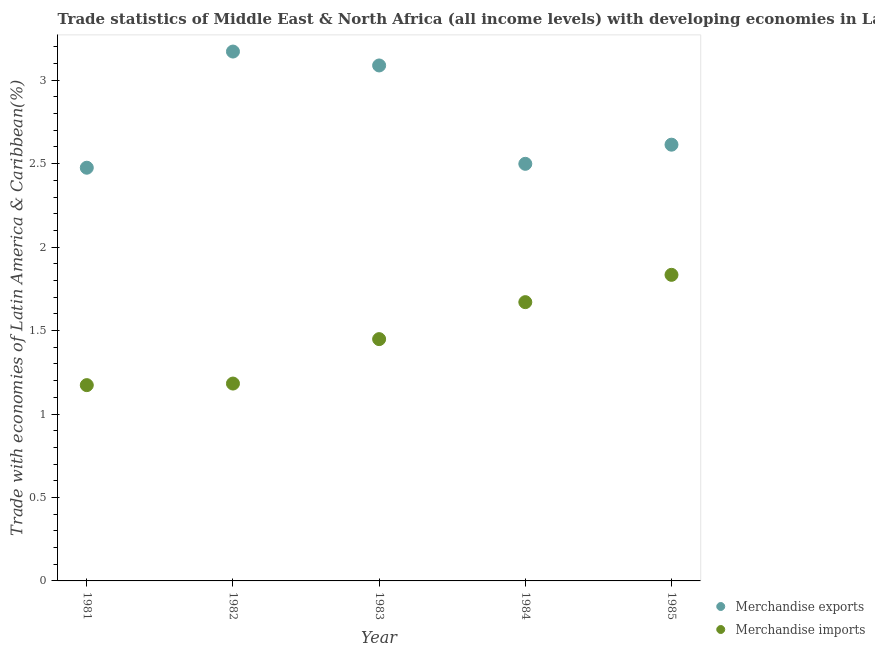What is the merchandise exports in 1981?
Keep it short and to the point. 2.48. Across all years, what is the maximum merchandise exports?
Offer a very short reply. 3.17. Across all years, what is the minimum merchandise imports?
Provide a short and direct response. 1.17. In which year was the merchandise imports minimum?
Keep it short and to the point. 1981. What is the total merchandise imports in the graph?
Give a very brief answer. 7.31. What is the difference between the merchandise imports in 1981 and that in 1983?
Offer a terse response. -0.28. What is the difference between the merchandise exports in 1982 and the merchandise imports in 1983?
Offer a terse response. 1.72. What is the average merchandise exports per year?
Your response must be concise. 2.77. In the year 1985, what is the difference between the merchandise imports and merchandise exports?
Ensure brevity in your answer.  -0.78. What is the ratio of the merchandise imports in 1982 to that in 1984?
Make the answer very short. 0.71. Is the merchandise exports in 1982 less than that in 1985?
Give a very brief answer. No. What is the difference between the highest and the second highest merchandise imports?
Keep it short and to the point. 0.16. What is the difference between the highest and the lowest merchandise exports?
Offer a terse response. 0.7. Is the sum of the merchandise imports in 1983 and 1985 greater than the maximum merchandise exports across all years?
Your answer should be very brief. Yes. Is the merchandise exports strictly less than the merchandise imports over the years?
Offer a terse response. No. How many dotlines are there?
Ensure brevity in your answer.  2. How many years are there in the graph?
Make the answer very short. 5. What is the difference between two consecutive major ticks on the Y-axis?
Your answer should be compact. 0.5. Does the graph contain any zero values?
Your answer should be compact. No. Where does the legend appear in the graph?
Offer a terse response. Bottom right. How many legend labels are there?
Keep it short and to the point. 2. What is the title of the graph?
Your response must be concise. Trade statistics of Middle East & North Africa (all income levels) with developing economies in Latin America. What is the label or title of the X-axis?
Offer a very short reply. Year. What is the label or title of the Y-axis?
Offer a very short reply. Trade with economies of Latin America & Caribbean(%). What is the Trade with economies of Latin America & Caribbean(%) in Merchandise exports in 1981?
Provide a succinct answer. 2.48. What is the Trade with economies of Latin America & Caribbean(%) in Merchandise imports in 1981?
Your answer should be compact. 1.17. What is the Trade with economies of Latin America & Caribbean(%) in Merchandise exports in 1982?
Offer a very short reply. 3.17. What is the Trade with economies of Latin America & Caribbean(%) in Merchandise imports in 1982?
Ensure brevity in your answer.  1.18. What is the Trade with economies of Latin America & Caribbean(%) in Merchandise exports in 1983?
Ensure brevity in your answer.  3.09. What is the Trade with economies of Latin America & Caribbean(%) in Merchandise imports in 1983?
Your answer should be compact. 1.45. What is the Trade with economies of Latin America & Caribbean(%) of Merchandise exports in 1984?
Offer a very short reply. 2.5. What is the Trade with economies of Latin America & Caribbean(%) in Merchandise imports in 1984?
Ensure brevity in your answer.  1.67. What is the Trade with economies of Latin America & Caribbean(%) of Merchandise exports in 1985?
Offer a very short reply. 2.61. What is the Trade with economies of Latin America & Caribbean(%) in Merchandise imports in 1985?
Provide a succinct answer. 1.83. Across all years, what is the maximum Trade with economies of Latin America & Caribbean(%) of Merchandise exports?
Keep it short and to the point. 3.17. Across all years, what is the maximum Trade with economies of Latin America & Caribbean(%) of Merchandise imports?
Ensure brevity in your answer.  1.83. Across all years, what is the minimum Trade with economies of Latin America & Caribbean(%) of Merchandise exports?
Your answer should be very brief. 2.48. Across all years, what is the minimum Trade with economies of Latin America & Caribbean(%) in Merchandise imports?
Your answer should be very brief. 1.17. What is the total Trade with economies of Latin America & Caribbean(%) in Merchandise exports in the graph?
Give a very brief answer. 13.85. What is the total Trade with economies of Latin America & Caribbean(%) in Merchandise imports in the graph?
Keep it short and to the point. 7.31. What is the difference between the Trade with economies of Latin America & Caribbean(%) in Merchandise exports in 1981 and that in 1982?
Provide a short and direct response. -0.7. What is the difference between the Trade with economies of Latin America & Caribbean(%) of Merchandise imports in 1981 and that in 1982?
Your answer should be very brief. -0.01. What is the difference between the Trade with economies of Latin America & Caribbean(%) of Merchandise exports in 1981 and that in 1983?
Your answer should be compact. -0.61. What is the difference between the Trade with economies of Latin America & Caribbean(%) in Merchandise imports in 1981 and that in 1983?
Your answer should be compact. -0.28. What is the difference between the Trade with economies of Latin America & Caribbean(%) in Merchandise exports in 1981 and that in 1984?
Your response must be concise. -0.02. What is the difference between the Trade with economies of Latin America & Caribbean(%) in Merchandise imports in 1981 and that in 1984?
Offer a very short reply. -0.5. What is the difference between the Trade with economies of Latin America & Caribbean(%) of Merchandise exports in 1981 and that in 1985?
Make the answer very short. -0.14. What is the difference between the Trade with economies of Latin America & Caribbean(%) in Merchandise imports in 1981 and that in 1985?
Make the answer very short. -0.66. What is the difference between the Trade with economies of Latin America & Caribbean(%) in Merchandise exports in 1982 and that in 1983?
Provide a succinct answer. 0.08. What is the difference between the Trade with economies of Latin America & Caribbean(%) in Merchandise imports in 1982 and that in 1983?
Give a very brief answer. -0.27. What is the difference between the Trade with economies of Latin America & Caribbean(%) in Merchandise exports in 1982 and that in 1984?
Provide a short and direct response. 0.67. What is the difference between the Trade with economies of Latin America & Caribbean(%) in Merchandise imports in 1982 and that in 1984?
Your response must be concise. -0.49. What is the difference between the Trade with economies of Latin America & Caribbean(%) in Merchandise exports in 1982 and that in 1985?
Your response must be concise. 0.56. What is the difference between the Trade with economies of Latin America & Caribbean(%) in Merchandise imports in 1982 and that in 1985?
Your answer should be very brief. -0.65. What is the difference between the Trade with economies of Latin America & Caribbean(%) in Merchandise exports in 1983 and that in 1984?
Give a very brief answer. 0.59. What is the difference between the Trade with economies of Latin America & Caribbean(%) in Merchandise imports in 1983 and that in 1984?
Offer a very short reply. -0.22. What is the difference between the Trade with economies of Latin America & Caribbean(%) in Merchandise exports in 1983 and that in 1985?
Keep it short and to the point. 0.47. What is the difference between the Trade with economies of Latin America & Caribbean(%) of Merchandise imports in 1983 and that in 1985?
Give a very brief answer. -0.39. What is the difference between the Trade with economies of Latin America & Caribbean(%) of Merchandise exports in 1984 and that in 1985?
Offer a very short reply. -0.11. What is the difference between the Trade with economies of Latin America & Caribbean(%) in Merchandise imports in 1984 and that in 1985?
Provide a succinct answer. -0.16. What is the difference between the Trade with economies of Latin America & Caribbean(%) of Merchandise exports in 1981 and the Trade with economies of Latin America & Caribbean(%) of Merchandise imports in 1982?
Offer a terse response. 1.29. What is the difference between the Trade with economies of Latin America & Caribbean(%) in Merchandise exports in 1981 and the Trade with economies of Latin America & Caribbean(%) in Merchandise imports in 1983?
Offer a terse response. 1.03. What is the difference between the Trade with economies of Latin America & Caribbean(%) in Merchandise exports in 1981 and the Trade with economies of Latin America & Caribbean(%) in Merchandise imports in 1984?
Offer a terse response. 0.81. What is the difference between the Trade with economies of Latin America & Caribbean(%) of Merchandise exports in 1981 and the Trade with economies of Latin America & Caribbean(%) of Merchandise imports in 1985?
Ensure brevity in your answer.  0.64. What is the difference between the Trade with economies of Latin America & Caribbean(%) of Merchandise exports in 1982 and the Trade with economies of Latin America & Caribbean(%) of Merchandise imports in 1983?
Your response must be concise. 1.72. What is the difference between the Trade with economies of Latin America & Caribbean(%) in Merchandise exports in 1982 and the Trade with economies of Latin America & Caribbean(%) in Merchandise imports in 1984?
Make the answer very short. 1.5. What is the difference between the Trade with economies of Latin America & Caribbean(%) in Merchandise exports in 1982 and the Trade with economies of Latin America & Caribbean(%) in Merchandise imports in 1985?
Ensure brevity in your answer.  1.34. What is the difference between the Trade with economies of Latin America & Caribbean(%) of Merchandise exports in 1983 and the Trade with economies of Latin America & Caribbean(%) of Merchandise imports in 1984?
Provide a succinct answer. 1.42. What is the difference between the Trade with economies of Latin America & Caribbean(%) in Merchandise exports in 1983 and the Trade with economies of Latin America & Caribbean(%) in Merchandise imports in 1985?
Your answer should be compact. 1.25. What is the difference between the Trade with economies of Latin America & Caribbean(%) of Merchandise exports in 1984 and the Trade with economies of Latin America & Caribbean(%) of Merchandise imports in 1985?
Your answer should be compact. 0.67. What is the average Trade with economies of Latin America & Caribbean(%) in Merchandise exports per year?
Offer a terse response. 2.77. What is the average Trade with economies of Latin America & Caribbean(%) in Merchandise imports per year?
Give a very brief answer. 1.46. In the year 1981, what is the difference between the Trade with economies of Latin America & Caribbean(%) in Merchandise exports and Trade with economies of Latin America & Caribbean(%) in Merchandise imports?
Your answer should be compact. 1.3. In the year 1982, what is the difference between the Trade with economies of Latin America & Caribbean(%) in Merchandise exports and Trade with economies of Latin America & Caribbean(%) in Merchandise imports?
Provide a short and direct response. 1.99. In the year 1983, what is the difference between the Trade with economies of Latin America & Caribbean(%) in Merchandise exports and Trade with economies of Latin America & Caribbean(%) in Merchandise imports?
Ensure brevity in your answer.  1.64. In the year 1984, what is the difference between the Trade with economies of Latin America & Caribbean(%) of Merchandise exports and Trade with economies of Latin America & Caribbean(%) of Merchandise imports?
Provide a succinct answer. 0.83. In the year 1985, what is the difference between the Trade with economies of Latin America & Caribbean(%) of Merchandise exports and Trade with economies of Latin America & Caribbean(%) of Merchandise imports?
Offer a very short reply. 0.78. What is the ratio of the Trade with economies of Latin America & Caribbean(%) in Merchandise exports in 1981 to that in 1982?
Your answer should be very brief. 0.78. What is the ratio of the Trade with economies of Latin America & Caribbean(%) in Merchandise imports in 1981 to that in 1982?
Ensure brevity in your answer.  0.99. What is the ratio of the Trade with economies of Latin America & Caribbean(%) of Merchandise exports in 1981 to that in 1983?
Keep it short and to the point. 0.8. What is the ratio of the Trade with economies of Latin America & Caribbean(%) in Merchandise imports in 1981 to that in 1983?
Offer a very short reply. 0.81. What is the ratio of the Trade with economies of Latin America & Caribbean(%) of Merchandise exports in 1981 to that in 1984?
Offer a terse response. 0.99. What is the ratio of the Trade with economies of Latin America & Caribbean(%) of Merchandise imports in 1981 to that in 1984?
Provide a short and direct response. 0.7. What is the ratio of the Trade with economies of Latin America & Caribbean(%) in Merchandise exports in 1981 to that in 1985?
Keep it short and to the point. 0.95. What is the ratio of the Trade with economies of Latin America & Caribbean(%) of Merchandise imports in 1981 to that in 1985?
Ensure brevity in your answer.  0.64. What is the ratio of the Trade with economies of Latin America & Caribbean(%) of Merchandise exports in 1982 to that in 1983?
Your answer should be compact. 1.03. What is the ratio of the Trade with economies of Latin America & Caribbean(%) in Merchandise imports in 1982 to that in 1983?
Your answer should be very brief. 0.82. What is the ratio of the Trade with economies of Latin America & Caribbean(%) in Merchandise exports in 1982 to that in 1984?
Offer a very short reply. 1.27. What is the ratio of the Trade with economies of Latin America & Caribbean(%) of Merchandise imports in 1982 to that in 1984?
Ensure brevity in your answer.  0.71. What is the ratio of the Trade with economies of Latin America & Caribbean(%) of Merchandise exports in 1982 to that in 1985?
Provide a succinct answer. 1.21. What is the ratio of the Trade with economies of Latin America & Caribbean(%) of Merchandise imports in 1982 to that in 1985?
Offer a terse response. 0.64. What is the ratio of the Trade with economies of Latin America & Caribbean(%) of Merchandise exports in 1983 to that in 1984?
Ensure brevity in your answer.  1.24. What is the ratio of the Trade with economies of Latin America & Caribbean(%) in Merchandise imports in 1983 to that in 1984?
Your response must be concise. 0.87. What is the ratio of the Trade with economies of Latin America & Caribbean(%) of Merchandise exports in 1983 to that in 1985?
Offer a terse response. 1.18. What is the ratio of the Trade with economies of Latin America & Caribbean(%) in Merchandise imports in 1983 to that in 1985?
Your answer should be compact. 0.79. What is the ratio of the Trade with economies of Latin America & Caribbean(%) in Merchandise exports in 1984 to that in 1985?
Provide a short and direct response. 0.96. What is the ratio of the Trade with economies of Latin America & Caribbean(%) in Merchandise imports in 1984 to that in 1985?
Ensure brevity in your answer.  0.91. What is the difference between the highest and the second highest Trade with economies of Latin America & Caribbean(%) in Merchandise exports?
Keep it short and to the point. 0.08. What is the difference between the highest and the second highest Trade with economies of Latin America & Caribbean(%) in Merchandise imports?
Offer a terse response. 0.16. What is the difference between the highest and the lowest Trade with economies of Latin America & Caribbean(%) in Merchandise exports?
Offer a very short reply. 0.7. What is the difference between the highest and the lowest Trade with economies of Latin America & Caribbean(%) in Merchandise imports?
Your answer should be very brief. 0.66. 